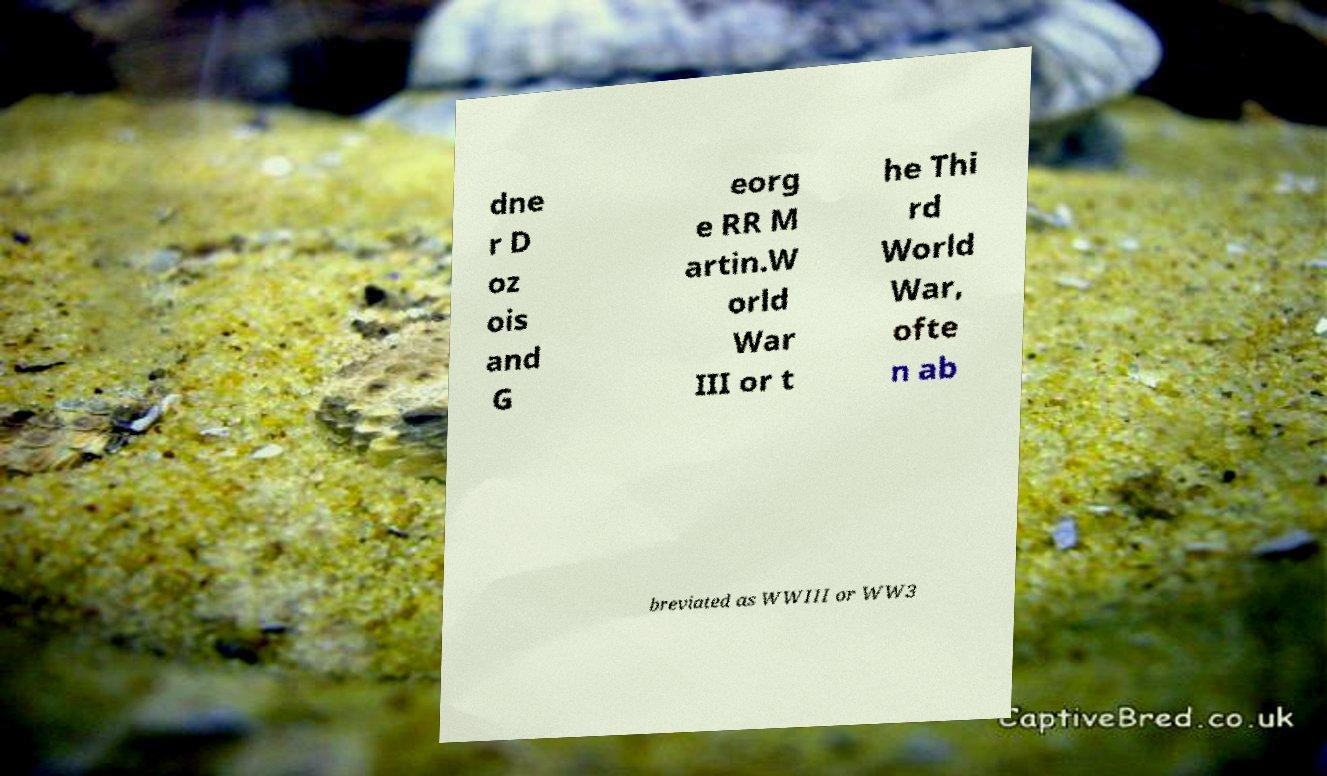Please read and relay the text visible in this image. What does it say? dne r D oz ois and G eorg e RR M artin.W orld War III or t he Thi rd World War, ofte n ab breviated as WWIII or WW3 